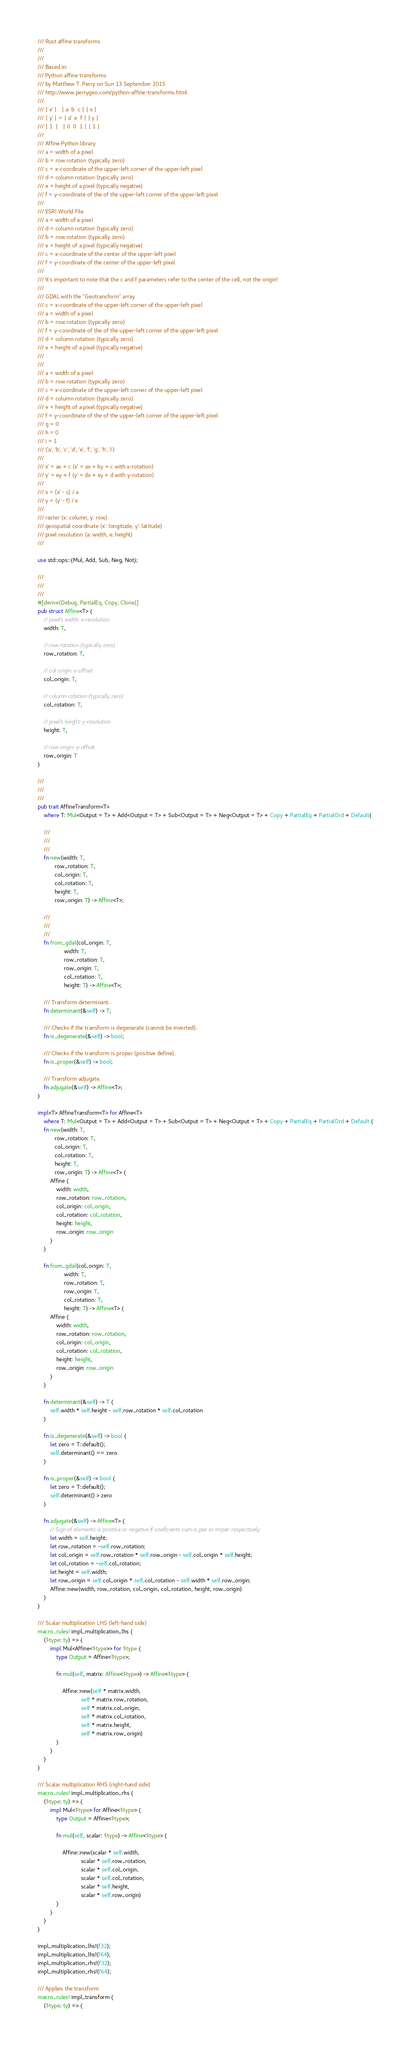Convert code to text. <code><loc_0><loc_0><loc_500><loc_500><_Rust_>/// Rust affine transforms
///
///
/// Based in:
/// Python affine transforms
/// by Matthew T. Perry on Sun 13 September 2015
/// http://www.perrygeo.com/python-affine-transforms.html
///
/// | x' |   | a  b  c | | x |
/// | y' | = | d  e  f | | y |
/// | 1  |   | 0  0  1 | | 1 |
///
/// Affine Python library
/// a = width of a pixel
/// b = row rotation (typically zero)
/// c = x-coordinate of the upper-left corner of the upper-left pixel
/// d = column rotation (typically zero)
/// e = height of a pixel (typically negative)
/// f = y-coordinate of the of the upper-left corner of the upper-left pixel
///
/// ESRI World File
/// a = width of a pixel
/// d = column rotation (typically zero)
/// b = row rotation (typically zero)
/// e = height of a pixel (typically negative)
/// c = x-coordinate of the center of the upper-left pixel
/// f = y-coordinate of the center of the upper-left pixel
///
/// It's important to note that the c and f parameters refer to the center of the cell, not the origin!
///
/// GDAL with the "Geotransform" array
/// c = x-coordinate of the upper-left corner of the upper-left pixel
/// a = width of a pixel
/// b = row rotation (typically zero)
/// f = y-coordinate of the of the upper-left corner of the upper-left pixel
/// d = column rotation (typically zero)
/// e = height of a pixel (typically negative)
///
///
/// a = width of a pixel
/// b = row rotation (typically zero)
/// c = x-coordinate of the upper-left corner of the upper-left pixel
/// d = column rotation (typically zero)
/// e = height of a pixel (typically negative)
/// f = y-coordinate of the of the upper-left corner of the upper-left pixel
/// g = 0
/// h = 0
/// i = 1
/// ('a', 'b', 'c', 'd', 'e', 'f', 'g', 'h', 'i')
///
/// x' = ax + c (x' = ax + by + c with x-rotation)
/// y' = ey + f (y' = dx + ey + d with y-rotation)
///
/// x = (x' - c) / a
/// y = (y' - f) / e
///
/// raster (x: column, y: row)
/// geospatial coordinate (x': longitude, y': latitude)
/// pixel resolution (a: width, e: height)
///

use std::ops::{Mul, Add, Sub, Neg, Not};

///
///
///
#[derive(Debug, PartialEq, Copy, Clone)]
pub struct Affine<T> {
    // pixel's width: x-resolution
    width: T,

    // row rotation (typically zero)
    row_rotation: T,

    // col origin: x-offset
    col_origin: T,

    // column rotation (typically zero)
    col_rotation: T,

    // pixel's height: y-resolution
    height: T,

    // row origin: y-offset
    row_origin: T
}

///
///
///
pub trait AffineTransform<T>
    where T: Mul<Output = T> + Add<Output = T> + Sub<Output = T> + Neg<Output = T> + Copy + PartialEq + PartialOrd + Default{

    ///
    ///
    ///
    fn new(width: T,
           row_rotation: T,
           col_origin: T,
           col_rotation: T,
           height: T,
           row_origin: T) -> Affine<T>;

    ///
    ///
    ///
    fn from_gdal(col_origin: T,
                 width: T,
                 row_rotation: T,
                 row_origin: T,
                 col_rotation: T,
                 height: T) -> Affine<T>;

    /// Transform determinant.
    fn determinant(&self) -> T;

    /// Checks if the transform is degenarate (cannot be inverted).
    fn is_degenerate(&self) -> bool;

    /// Checks if the transform is proper (positive define).
    fn is_proper(&self) -> bool;

    /// Transform adjugate.
    fn adjugate(&self) -> Affine<T>;
}

impl<T> AffineTransform<T> for Affine<T>
    where T: Mul<Output = T> + Add<Output = T> + Sub<Output = T> + Neg<Output = T> + Copy + PartialEq + PartialOrd + Default {
    fn new(width: T,
           row_rotation: T,
           col_origin: T,
           col_rotation: T,
           height: T,
           row_origin: T) -> Affine<T> {
        Affine {
            width: width,
            row_rotation: row_rotation,
            col_origin: col_origin,
            col_rotation: col_rotation,
            height: height,
            row_origin: row_origin
        }
    }

    fn from_gdal(col_origin: T,
                 width: T,
                 row_rotation: T,
                 row_origin: T,
                 col_rotation: T,
                 height: T) -> Affine<T> {
        Affine {
            width: width,
            row_rotation: row_rotation,
            col_origin: col_origin,
            col_rotation: col_rotation,
            height: height,
            row_origin: row_origin
        }
    }

    fn determinant(&self) -> T {
        self.width * self.height - self.row_rotation * self.col_rotation
    }

    fn is_degenerate(&self) -> bool {
        let zero = T::default();
        self.determinant() == zero
    }

    fn is_proper(&self) -> bool {
        let zero = T::default();
        self.determinant() > zero
    }

    fn adjugate(&self) -> Affine<T> {
        // Sign of elements is positive or negative if coeficients sum is pair or impair respectively.
        let width = self.height;
        let row_rotation = -self.row_rotation;
        let col_origin = self.row_rotation * self.row_origin - self.col_origin * self.height;
        let col_rotation = -self.col_rotation;
        let height = self.width;
        let row_origin = self.col_origin * self.col_rotation - self.width * self.row_origin;
        Affine::new(width, row_rotation, col_origin, col_rotation, height, row_origin)
    }
}

/// Scalar multiplication LHS (left-hand side)
macro_rules! impl_multiplication_lhs {
    ($type: ty) => {
        impl Mul<Affine<$type>> for $type {
            type Output = Affine<$type>;

            fn mul(self, matrix: Affine<$type>) -> Affine<$type> {

                Affine::new(self * matrix.width,
                            self * matrix.row_rotation,
                            self * matrix.col_origin,
                            self * matrix.col_rotation,
                            self * matrix.height,
                            self * matrix.row_origin)
            }
        }
    }
}

/// Scalar multiplication RHS (right-hand side)
macro_rules! impl_multiplication_rhs {
    ($type: ty) => {
        impl Mul<$type> for Affine<$type> {
            type Output = Affine<$type>;

            fn mul(self, scalar: $type) -> Affine<$type> {

                Affine::new(scalar * self.width,
                            scalar * self.row_rotation,
                            scalar * self.col_origin,
                            scalar * self.col_rotation,
                            scalar * self.height,
                            scalar * self.row_origin)
            }
        }
    }
}

impl_multiplication_lhs!(f32);
impl_multiplication_lhs!(f64);
impl_multiplication_rhs!(f32);
impl_multiplication_rhs!(f64);

/// Applies the transform
macro_rules! impl_transform {
    ($type: ty) => {</code> 